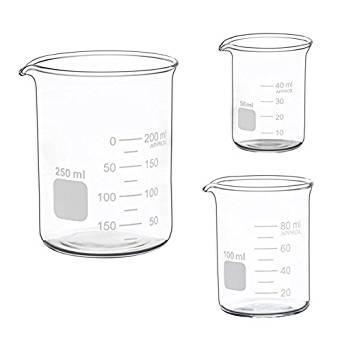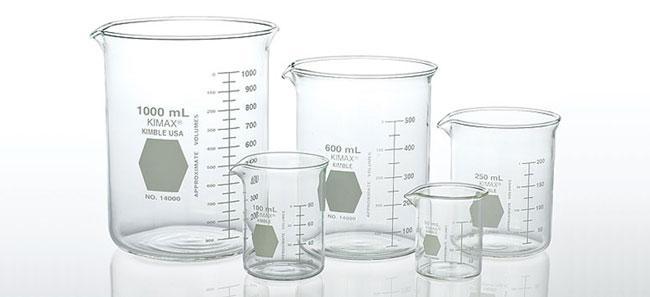The first image is the image on the left, the second image is the image on the right. Evaluate the accuracy of this statement regarding the images: "An image contains exactly three empty measuring cups, which are arranged in one horizontal row.". Is it true? Answer yes or no. No. The first image is the image on the left, the second image is the image on the right. For the images displayed, is the sentence "Exactly eight clear empty beakers are divided into two groupings, one with five beakers of different sizes and the other with three of different sizes." factually correct? Answer yes or no. Yes. 